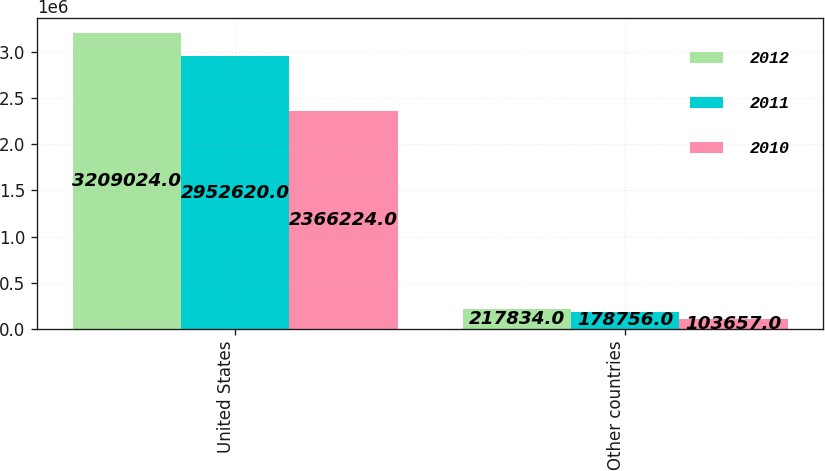<chart> <loc_0><loc_0><loc_500><loc_500><stacked_bar_chart><ecel><fcel>United States<fcel>Other countries<nl><fcel>2012<fcel>3.20902e+06<fcel>217834<nl><fcel>2011<fcel>2.95262e+06<fcel>178756<nl><fcel>2010<fcel>2.36622e+06<fcel>103657<nl></chart> 